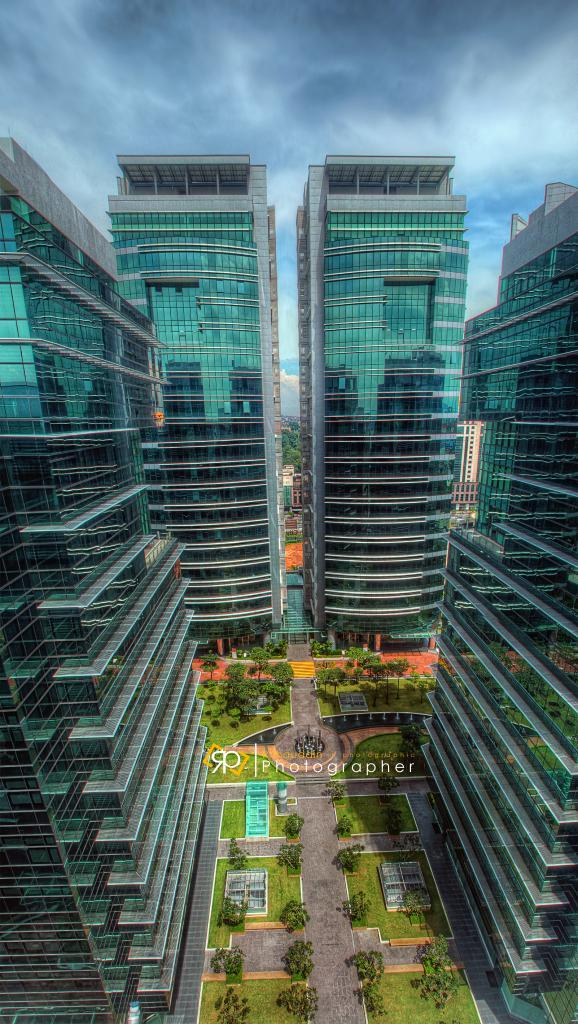What type of structures are present in the image? There are buildings in the image. What is the color of the buildings? The buildings are green in color. What can be seen on the ground in the image? The ground is visible in the image. What type of vegetation is present in the image? There are trees and grass in the image. What type of pathway is visible in the image? There is a road in the image. What is visible in the background of the image? The sky is visible in the background of the image. How many geese are swimming in the pocket in the image? There are no geese or pockets present in the image. 